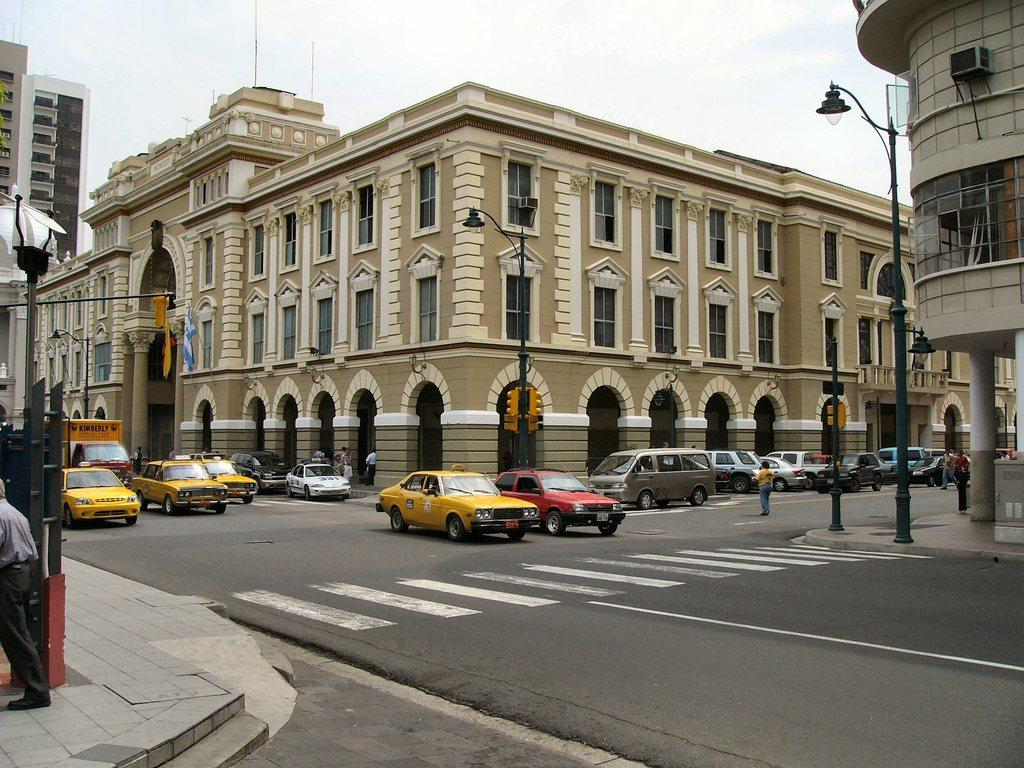What type of vehicles can be seen in the image? There are cars in the image. What structures are present in the image? There are buildings in the image. Are there any people visible in the image? Yes, there are persons in the image. What are the street poles used for in the image? The street poles are beside the road in the image. What is visible at the top of the image? The sky is visible at the top of the image. What type of acoustics can be heard from the cars in the image? There is no information about the acoustics of the cars in the image, as it only provides visual details. Can you tell me how many blades are attached to the street poles in the image? There is no mention of blades in the image; the street poles are simply beside the road. 